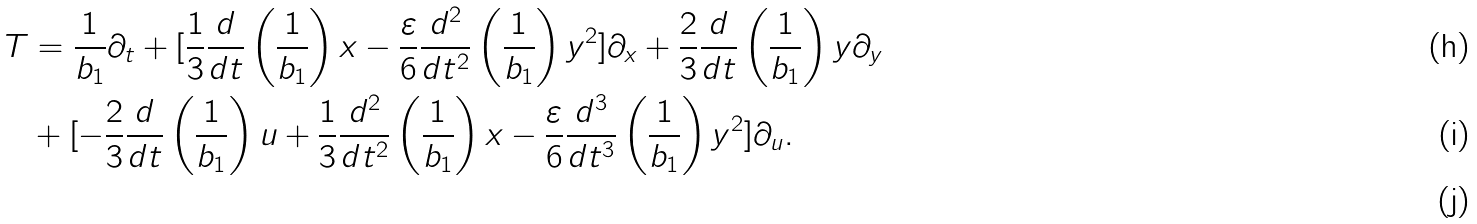Convert formula to latex. <formula><loc_0><loc_0><loc_500><loc_500>T & = \frac { 1 } { b _ { 1 } } \partial _ { t } + [ \frac { 1 } { 3 } \frac { d } { d t } \left ( { \frac { 1 } { b _ { 1 } } } \right ) x - \frac { \varepsilon } { 6 } \frac { d ^ { 2 } } { d t ^ { 2 } } \left ( { \frac { 1 } { b _ { 1 } } } \right ) y ^ { 2 } ] \partial _ { x } + \frac { 2 } { 3 } \frac { d } { d t } \left ( { \frac { 1 } { b _ { 1 } } } \right ) y \partial _ { y } \\ & + [ - \frac { 2 } { 3 } \frac { d } { d t } \left ( { \frac { 1 } { b _ { 1 } } } \right ) u + \frac { 1 } { 3 } \frac { d ^ { 2 } } { d t ^ { 2 } } \left ( { \frac { 1 } { b _ { 1 } } } \right ) x - \frac { \varepsilon } { 6 } \frac { d ^ { 3 } } { d t ^ { 3 } } \left ( { \frac { 1 } { b _ { 1 } } } \right ) y ^ { 2 } ] \partial _ { u } . \\</formula> 